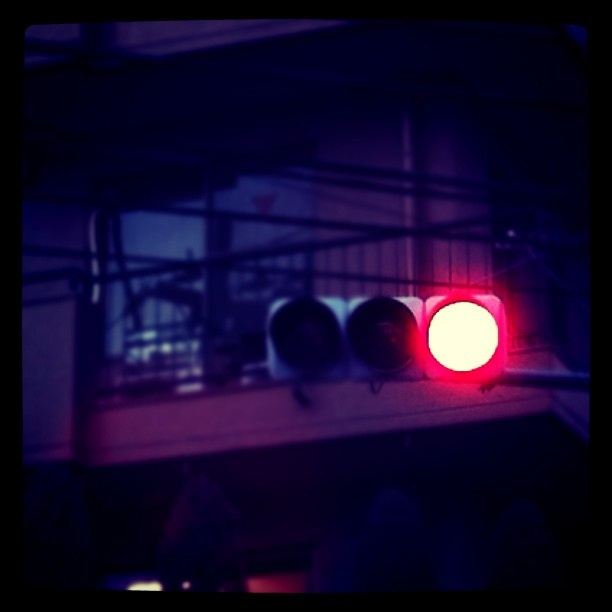Describe the objects in this image and their specific colors. I can see a traffic light in black, navy, lightyellow, and brown tones in this image. 